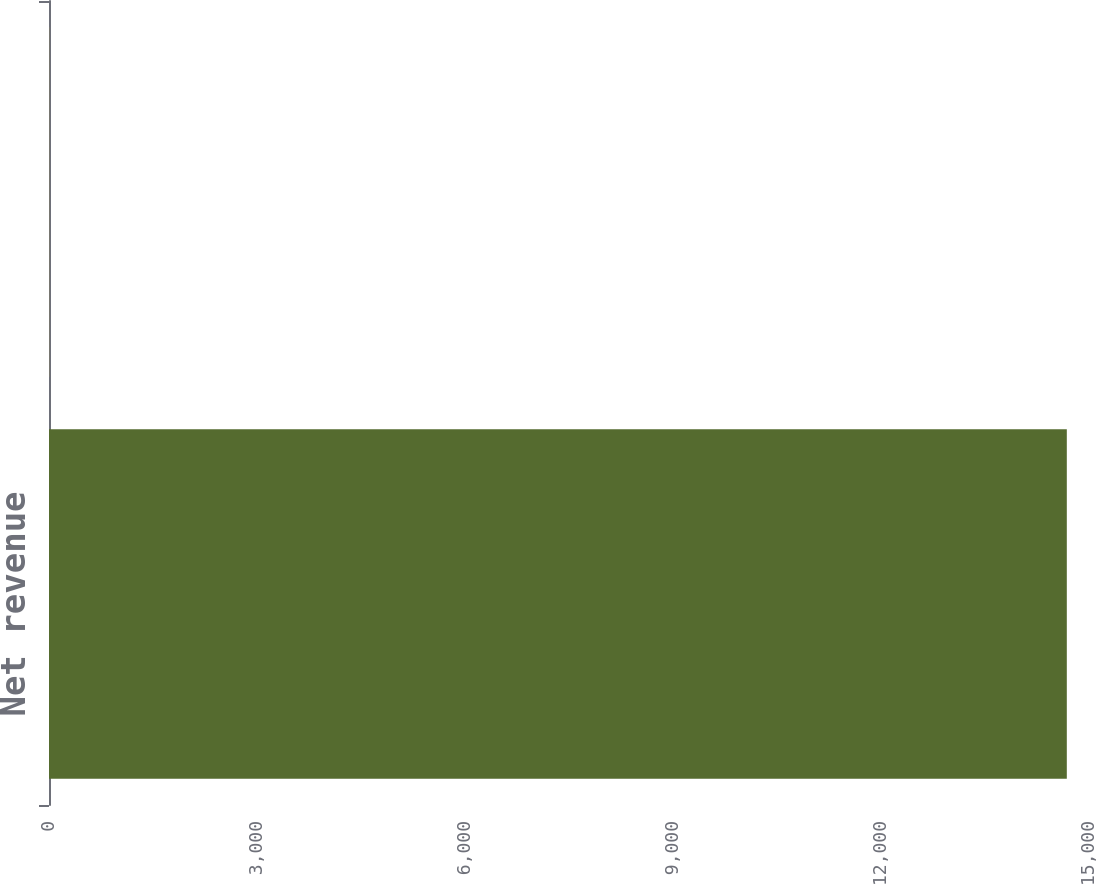Convert chart. <chart><loc_0><loc_0><loc_500><loc_500><bar_chart><fcel>Net revenue<fcel>Earnings (loss) from<nl><fcel>14680<fcel>1.6<nl></chart> 